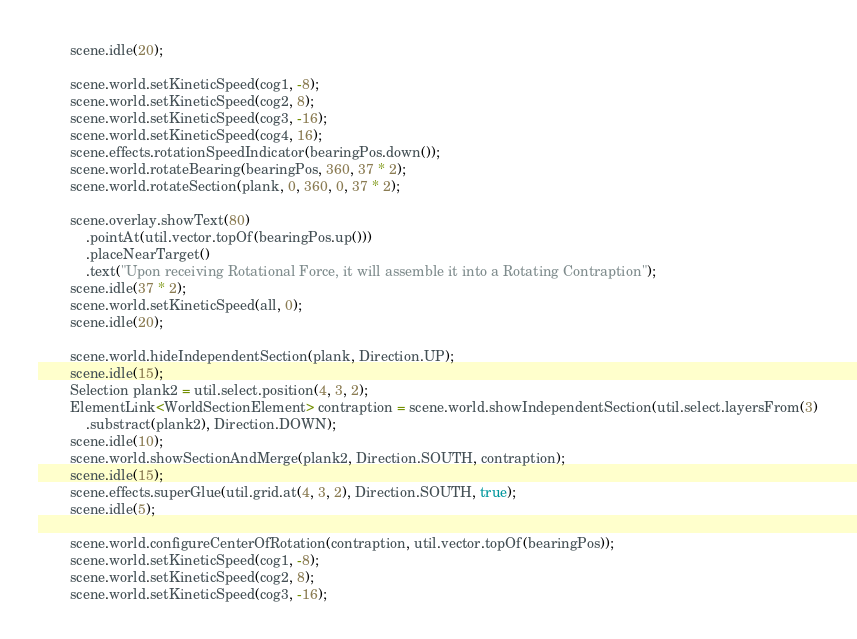<code> <loc_0><loc_0><loc_500><loc_500><_Java_>		scene.idle(20);

		scene.world.setKineticSpeed(cog1, -8);
		scene.world.setKineticSpeed(cog2, 8);
		scene.world.setKineticSpeed(cog3, -16);
		scene.world.setKineticSpeed(cog4, 16);
		scene.effects.rotationSpeedIndicator(bearingPos.down());
		scene.world.rotateBearing(bearingPos, 360, 37 * 2);
		scene.world.rotateSection(plank, 0, 360, 0, 37 * 2);

		scene.overlay.showText(80)
			.pointAt(util.vector.topOf(bearingPos.up()))
			.placeNearTarget()
			.text("Upon receiving Rotational Force, it will assemble it into a Rotating Contraption");
		scene.idle(37 * 2);
		scene.world.setKineticSpeed(all, 0);
		scene.idle(20);

		scene.world.hideIndependentSection(plank, Direction.UP);
		scene.idle(15);
		Selection plank2 = util.select.position(4, 3, 2);
		ElementLink<WorldSectionElement> contraption = scene.world.showIndependentSection(util.select.layersFrom(3)
			.substract(plank2), Direction.DOWN);
		scene.idle(10);
		scene.world.showSectionAndMerge(plank2, Direction.SOUTH, contraption);
		scene.idle(15);
		scene.effects.superGlue(util.grid.at(4, 3, 2), Direction.SOUTH, true);
		scene.idle(5);

		scene.world.configureCenterOfRotation(contraption, util.vector.topOf(bearingPos));
		scene.world.setKineticSpeed(cog1, -8);
		scene.world.setKineticSpeed(cog2, 8);
		scene.world.setKineticSpeed(cog3, -16);</code> 